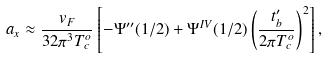Convert formula to latex. <formula><loc_0><loc_0><loc_500><loc_500>a _ { x } \approx \frac { v _ { F } } { 3 2 \pi ^ { 3 } T _ { c } ^ { o } } \left [ - \Psi ^ { \prime \prime } ( 1 / 2 ) + \Psi ^ { I V } ( 1 / 2 ) \left ( \frac { t _ { b } ^ { \prime } } { 2 \pi T _ { c } ^ { o } } \right ) ^ { 2 } \right ] ,</formula> 